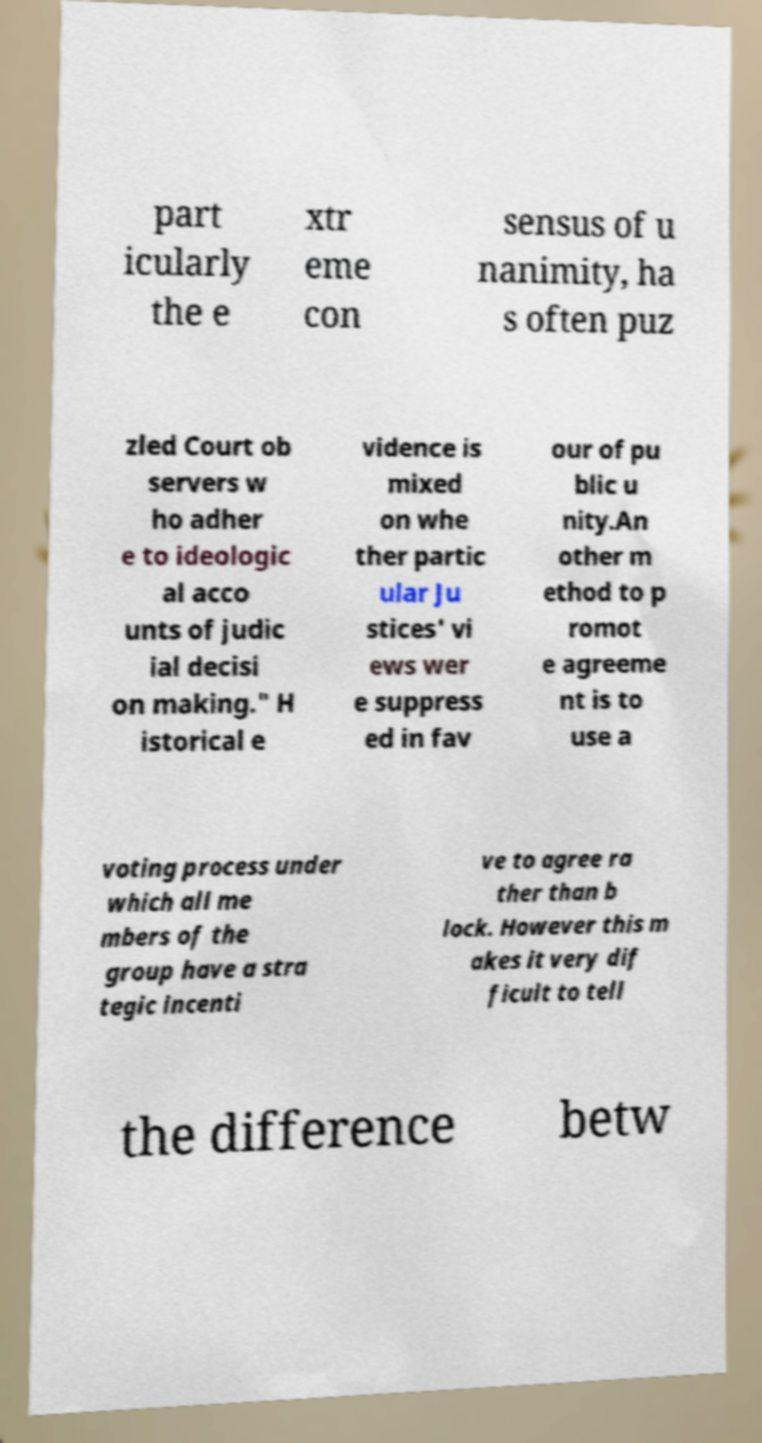Please read and relay the text visible in this image. What does it say? part icularly the e xtr eme con sensus of u nanimity, ha s often puz zled Court ob servers w ho adher e to ideologic al acco unts of judic ial decisi on making." H istorical e vidence is mixed on whe ther partic ular Ju stices' vi ews wer e suppress ed in fav our of pu blic u nity.An other m ethod to p romot e agreeme nt is to use a voting process under which all me mbers of the group have a stra tegic incenti ve to agree ra ther than b lock. However this m akes it very dif ficult to tell the difference betw 